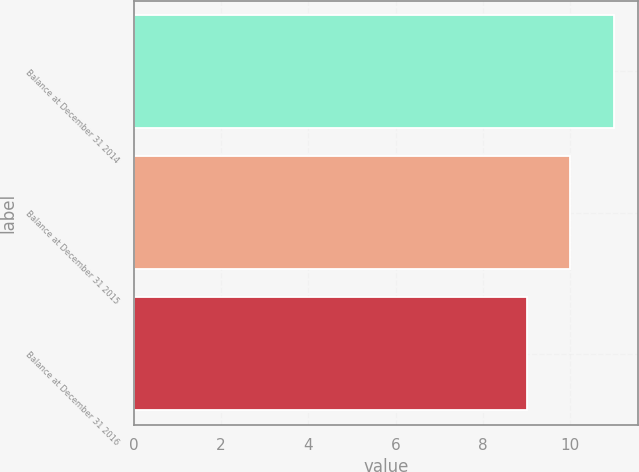Convert chart. <chart><loc_0><loc_0><loc_500><loc_500><bar_chart><fcel>Balance at December 31 2014<fcel>Balance at December 31 2015<fcel>Balance at December 31 2016<nl><fcel>11<fcel>10<fcel>9<nl></chart> 